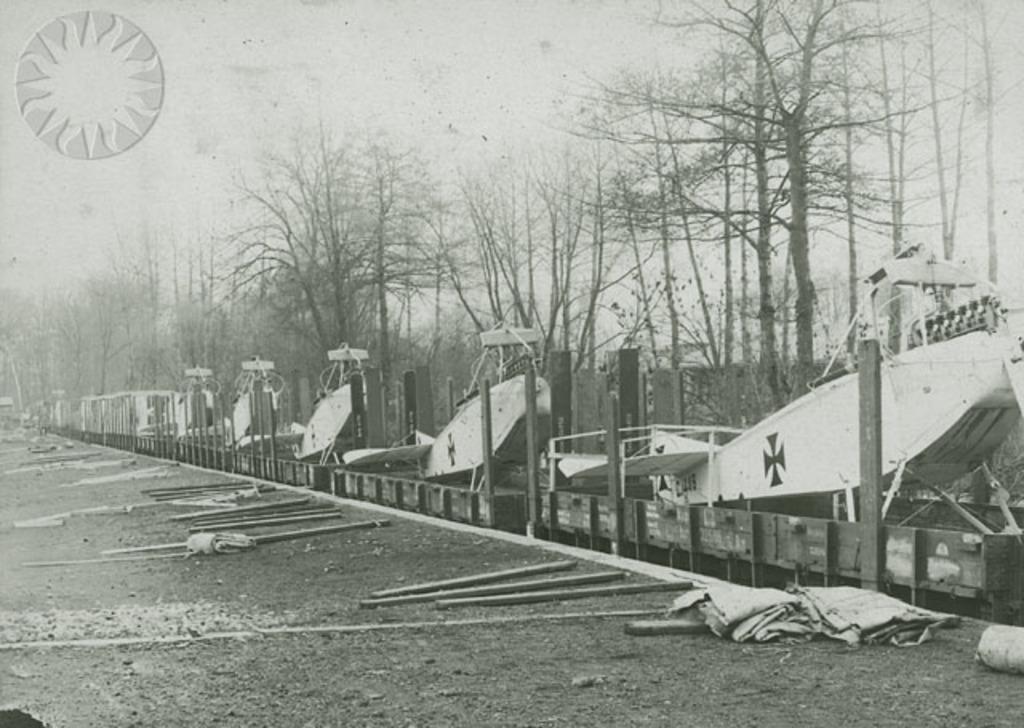Please provide a concise description of this image. In this picture we can see some fighter jets on the right side, at the bottom there are some stocks, we can see trees in the background, there is a logo at the left top of the picture, it is a black and white image. 